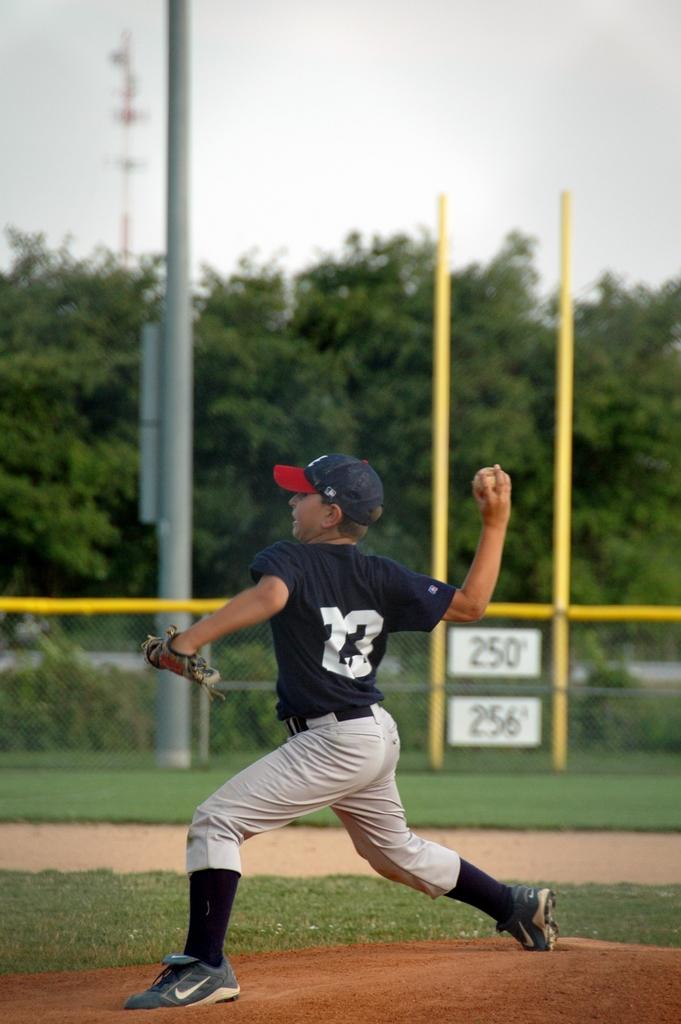What is the boy's jersey number?
Ensure brevity in your answer.  23. What number is on the bottom white sign?
Offer a very short reply. 256. 